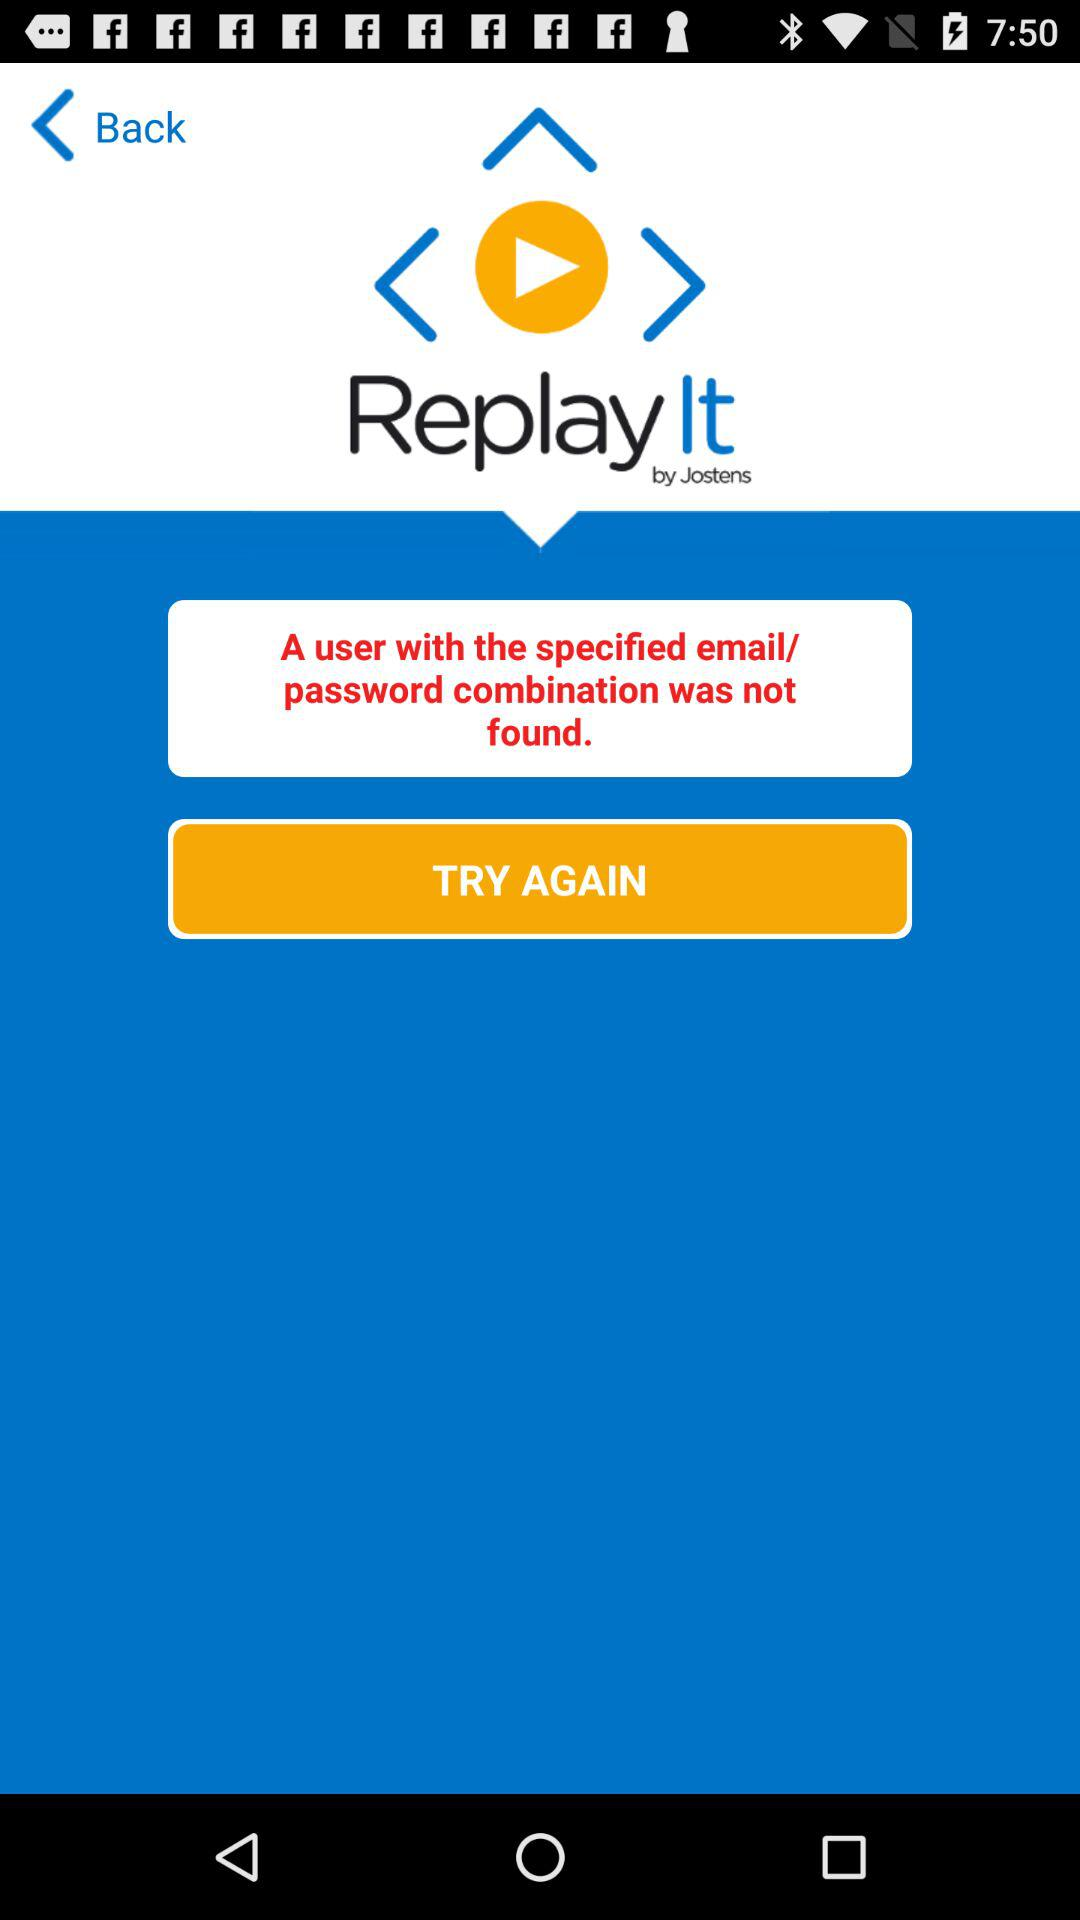What is the name of the application? The name of the application is "Replay It". 